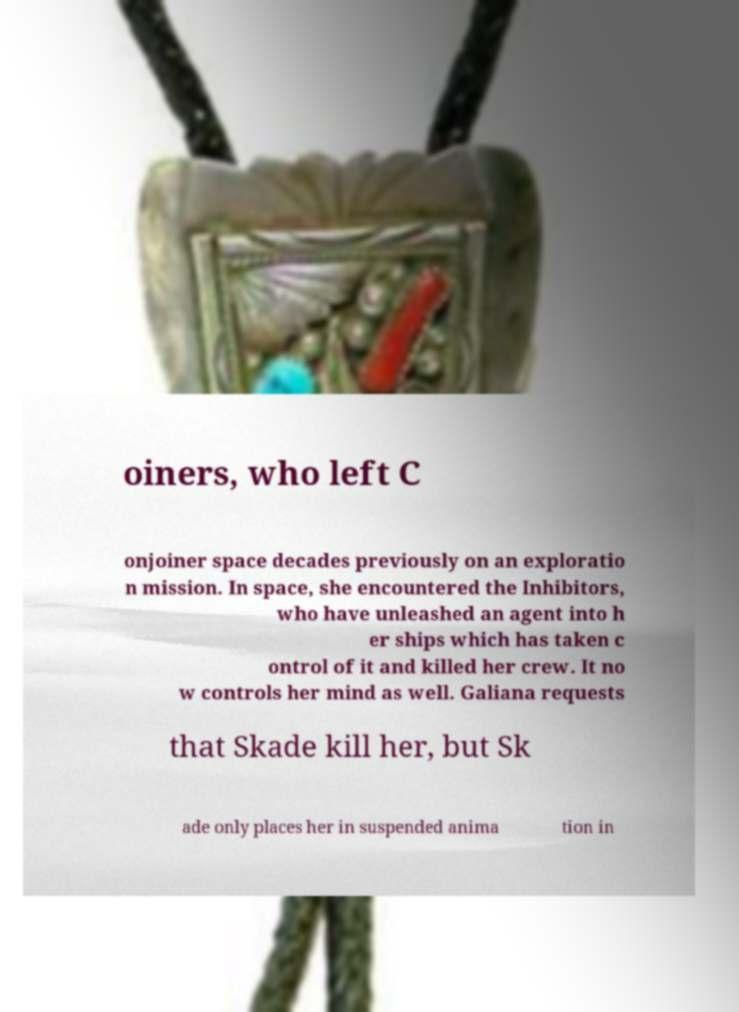Can you read and provide the text displayed in the image?This photo seems to have some interesting text. Can you extract and type it out for me? oiners, who left C onjoiner space decades previously on an exploratio n mission. In space, she encountered the Inhibitors, who have unleashed an agent into h er ships which has taken c ontrol of it and killed her crew. It no w controls her mind as well. Galiana requests that Skade kill her, but Sk ade only places her in suspended anima tion in 